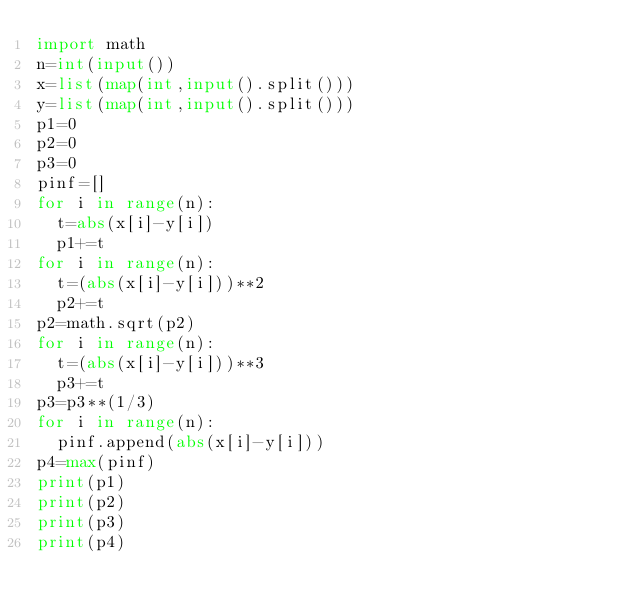Convert code to text. <code><loc_0><loc_0><loc_500><loc_500><_Python_>import math
n=int(input())
x=list(map(int,input().split()))
y=list(map(int,input().split()))
p1=0
p2=0
p3=0
pinf=[]
for i in range(n):
	t=abs(x[i]-y[i])
	p1+=t
for i in range(n):
	t=(abs(x[i]-y[i]))**2
	p2+=t
p2=math.sqrt(p2)
for i in range(n):
	t=(abs(x[i]-y[i]))**3
	p3+=t
p3=p3**(1/3)
for i in range(n):
	pinf.append(abs(x[i]-y[i]))
p4=max(pinf)
print(p1)
print(p2)
print(p3)
print(p4)
</code> 